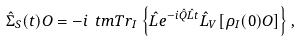<formula> <loc_0><loc_0><loc_500><loc_500>\hat { \Sigma } _ { S } ( t ) O = - i \ t m { T r } _ { I } \left \{ \hat { L } e ^ { - i \hat { Q } \hat { L } t } \hat { L } _ { V } [ \rho _ { I } ( 0 ) O ] \right \} ,</formula> 